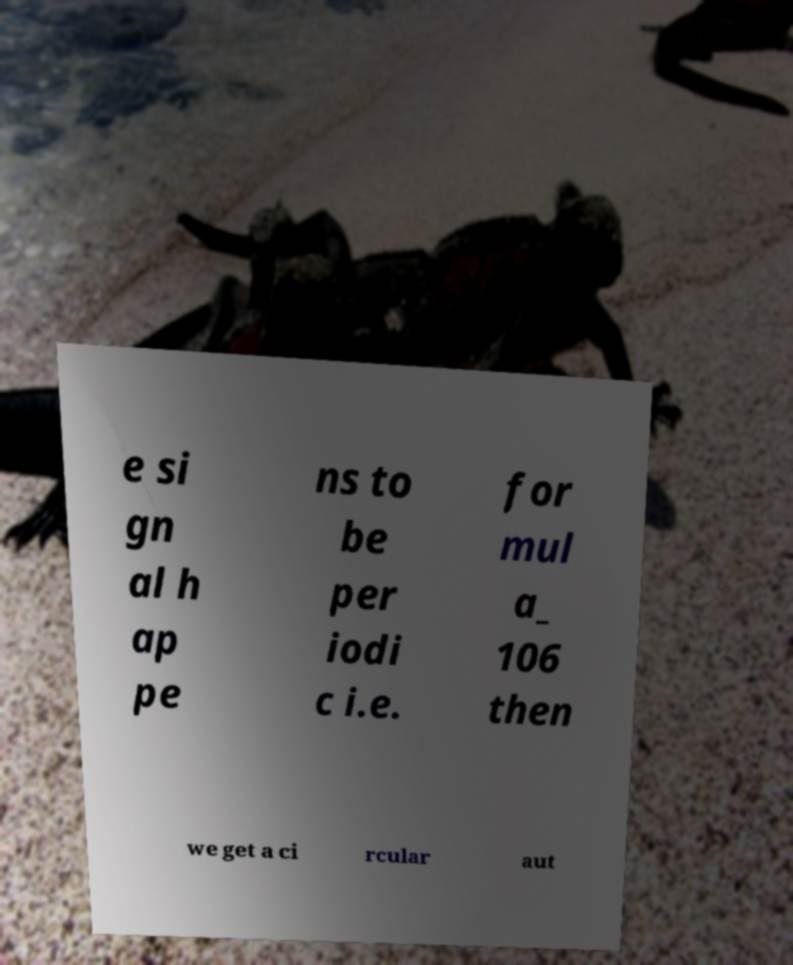I need the written content from this picture converted into text. Can you do that? e si gn al h ap pe ns to be per iodi c i.e. for mul a_ 106 then we get a ci rcular aut 